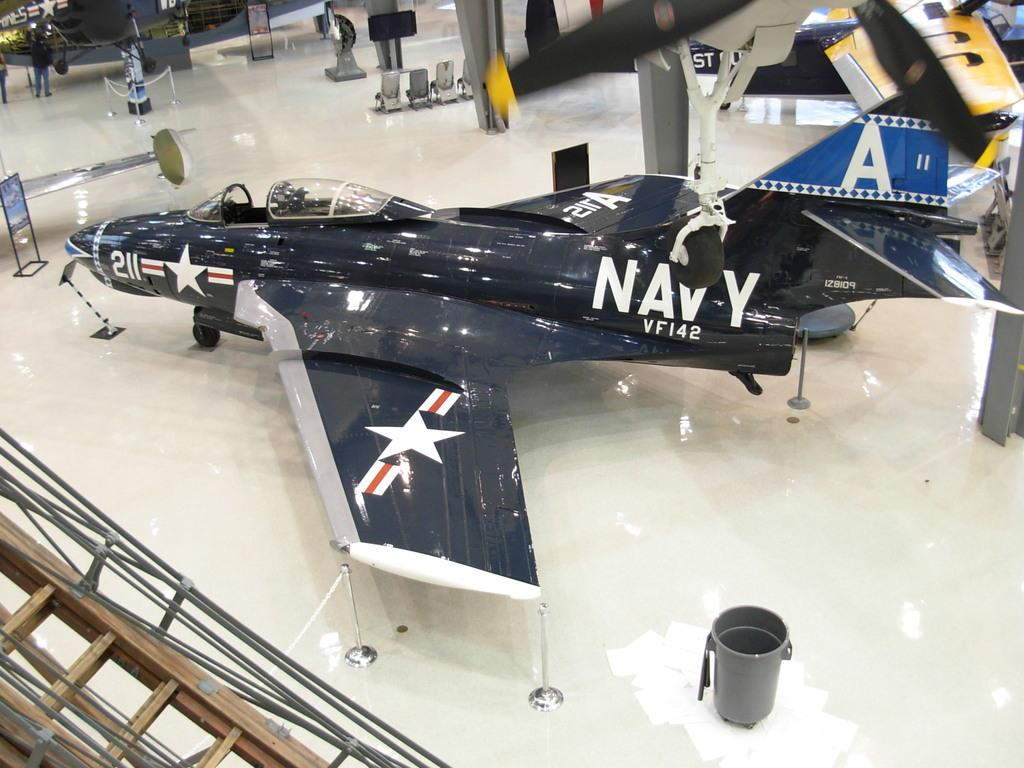Provide a one-sentence caption for the provided image. an image of a jet with the words NAVY VF142 on it. 